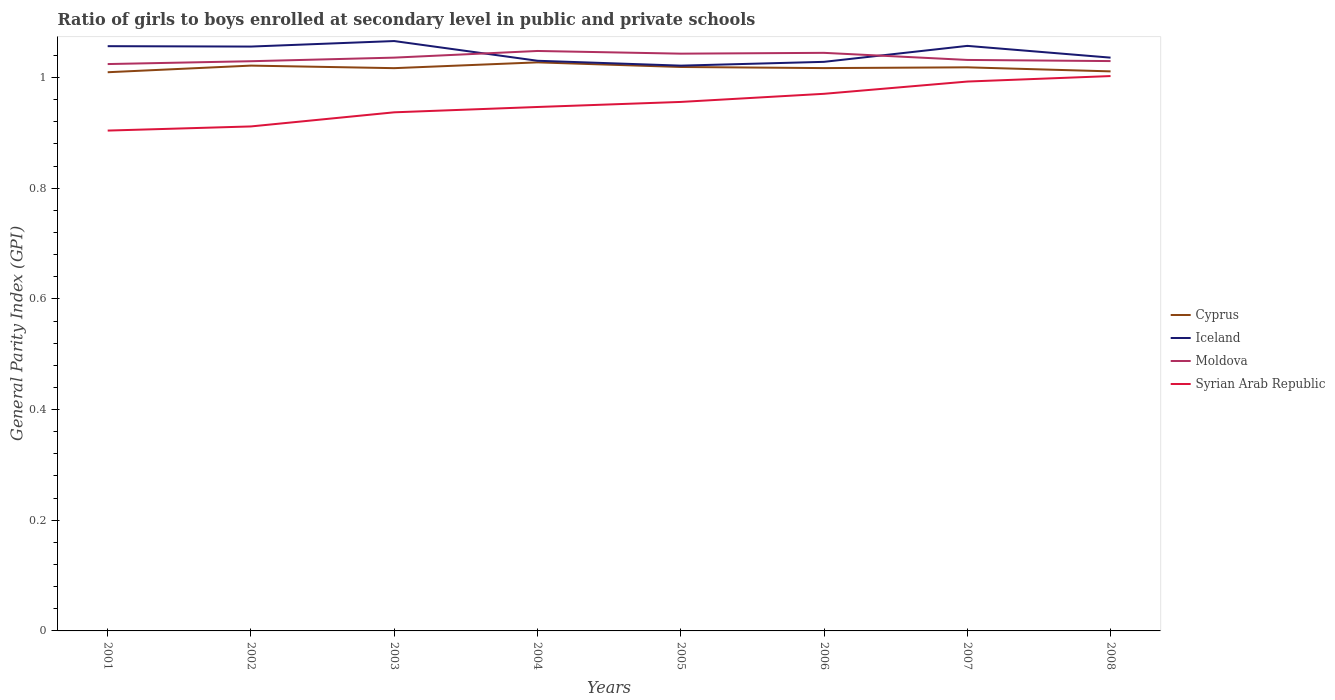How many different coloured lines are there?
Your response must be concise. 4. Does the line corresponding to Moldova intersect with the line corresponding to Iceland?
Make the answer very short. Yes. Across all years, what is the maximum general parity index in Moldova?
Your answer should be compact. 1.02. What is the total general parity index in Cyprus in the graph?
Ensure brevity in your answer.  -0. What is the difference between the highest and the second highest general parity index in Cyprus?
Give a very brief answer. 0.02. Is the general parity index in Iceland strictly greater than the general parity index in Syrian Arab Republic over the years?
Give a very brief answer. No. How many lines are there?
Provide a succinct answer. 4. Does the graph contain grids?
Make the answer very short. No. How many legend labels are there?
Keep it short and to the point. 4. What is the title of the graph?
Offer a terse response. Ratio of girls to boys enrolled at secondary level in public and private schools. Does "Greece" appear as one of the legend labels in the graph?
Your response must be concise. No. What is the label or title of the X-axis?
Ensure brevity in your answer.  Years. What is the label or title of the Y-axis?
Provide a short and direct response. General Parity Index (GPI). What is the General Parity Index (GPI) of Cyprus in 2001?
Offer a very short reply. 1.01. What is the General Parity Index (GPI) in Iceland in 2001?
Provide a succinct answer. 1.06. What is the General Parity Index (GPI) in Moldova in 2001?
Provide a short and direct response. 1.02. What is the General Parity Index (GPI) of Syrian Arab Republic in 2001?
Offer a terse response. 0.9. What is the General Parity Index (GPI) in Cyprus in 2002?
Provide a short and direct response. 1.02. What is the General Parity Index (GPI) in Iceland in 2002?
Your answer should be very brief. 1.06. What is the General Parity Index (GPI) in Moldova in 2002?
Provide a short and direct response. 1.03. What is the General Parity Index (GPI) of Syrian Arab Republic in 2002?
Give a very brief answer. 0.91. What is the General Parity Index (GPI) of Cyprus in 2003?
Make the answer very short. 1.02. What is the General Parity Index (GPI) of Iceland in 2003?
Your answer should be compact. 1.07. What is the General Parity Index (GPI) in Moldova in 2003?
Your response must be concise. 1.04. What is the General Parity Index (GPI) in Syrian Arab Republic in 2003?
Keep it short and to the point. 0.94. What is the General Parity Index (GPI) in Cyprus in 2004?
Keep it short and to the point. 1.03. What is the General Parity Index (GPI) in Iceland in 2004?
Provide a succinct answer. 1.03. What is the General Parity Index (GPI) in Moldova in 2004?
Your answer should be compact. 1.05. What is the General Parity Index (GPI) of Syrian Arab Republic in 2004?
Keep it short and to the point. 0.95. What is the General Parity Index (GPI) of Cyprus in 2005?
Give a very brief answer. 1.02. What is the General Parity Index (GPI) of Iceland in 2005?
Offer a very short reply. 1.02. What is the General Parity Index (GPI) of Moldova in 2005?
Ensure brevity in your answer.  1.04. What is the General Parity Index (GPI) in Syrian Arab Republic in 2005?
Provide a succinct answer. 0.96. What is the General Parity Index (GPI) of Cyprus in 2006?
Give a very brief answer. 1.02. What is the General Parity Index (GPI) in Iceland in 2006?
Offer a terse response. 1.03. What is the General Parity Index (GPI) in Moldova in 2006?
Offer a terse response. 1.04. What is the General Parity Index (GPI) of Syrian Arab Republic in 2006?
Provide a succinct answer. 0.97. What is the General Parity Index (GPI) of Cyprus in 2007?
Offer a very short reply. 1.02. What is the General Parity Index (GPI) of Iceland in 2007?
Your response must be concise. 1.06. What is the General Parity Index (GPI) in Moldova in 2007?
Give a very brief answer. 1.03. What is the General Parity Index (GPI) of Syrian Arab Republic in 2007?
Your response must be concise. 0.99. What is the General Parity Index (GPI) of Cyprus in 2008?
Ensure brevity in your answer.  1.01. What is the General Parity Index (GPI) of Iceland in 2008?
Give a very brief answer. 1.04. What is the General Parity Index (GPI) of Moldova in 2008?
Give a very brief answer. 1.03. What is the General Parity Index (GPI) of Syrian Arab Republic in 2008?
Offer a very short reply. 1. Across all years, what is the maximum General Parity Index (GPI) of Cyprus?
Make the answer very short. 1.03. Across all years, what is the maximum General Parity Index (GPI) in Iceland?
Ensure brevity in your answer.  1.07. Across all years, what is the maximum General Parity Index (GPI) of Moldova?
Keep it short and to the point. 1.05. Across all years, what is the maximum General Parity Index (GPI) of Syrian Arab Republic?
Provide a short and direct response. 1. Across all years, what is the minimum General Parity Index (GPI) of Cyprus?
Provide a succinct answer. 1.01. Across all years, what is the minimum General Parity Index (GPI) of Iceland?
Your answer should be very brief. 1.02. Across all years, what is the minimum General Parity Index (GPI) in Moldova?
Offer a terse response. 1.02. Across all years, what is the minimum General Parity Index (GPI) of Syrian Arab Republic?
Your answer should be very brief. 0.9. What is the total General Parity Index (GPI) of Cyprus in the graph?
Provide a short and direct response. 8.14. What is the total General Parity Index (GPI) of Iceland in the graph?
Offer a very short reply. 8.35. What is the total General Parity Index (GPI) of Moldova in the graph?
Offer a terse response. 8.29. What is the total General Parity Index (GPI) of Syrian Arab Republic in the graph?
Give a very brief answer. 7.62. What is the difference between the General Parity Index (GPI) in Cyprus in 2001 and that in 2002?
Make the answer very short. -0.01. What is the difference between the General Parity Index (GPI) in Iceland in 2001 and that in 2002?
Your response must be concise. 0. What is the difference between the General Parity Index (GPI) of Moldova in 2001 and that in 2002?
Your response must be concise. -0.01. What is the difference between the General Parity Index (GPI) in Syrian Arab Republic in 2001 and that in 2002?
Offer a terse response. -0.01. What is the difference between the General Parity Index (GPI) in Cyprus in 2001 and that in 2003?
Provide a short and direct response. -0.01. What is the difference between the General Parity Index (GPI) in Iceland in 2001 and that in 2003?
Your answer should be very brief. -0.01. What is the difference between the General Parity Index (GPI) in Moldova in 2001 and that in 2003?
Make the answer very short. -0.01. What is the difference between the General Parity Index (GPI) in Syrian Arab Republic in 2001 and that in 2003?
Keep it short and to the point. -0.03. What is the difference between the General Parity Index (GPI) of Cyprus in 2001 and that in 2004?
Offer a terse response. -0.02. What is the difference between the General Parity Index (GPI) of Iceland in 2001 and that in 2004?
Offer a very short reply. 0.03. What is the difference between the General Parity Index (GPI) in Moldova in 2001 and that in 2004?
Ensure brevity in your answer.  -0.02. What is the difference between the General Parity Index (GPI) in Syrian Arab Republic in 2001 and that in 2004?
Your response must be concise. -0.04. What is the difference between the General Parity Index (GPI) in Cyprus in 2001 and that in 2005?
Provide a short and direct response. -0.01. What is the difference between the General Parity Index (GPI) of Iceland in 2001 and that in 2005?
Offer a very short reply. 0.04. What is the difference between the General Parity Index (GPI) in Moldova in 2001 and that in 2005?
Give a very brief answer. -0.02. What is the difference between the General Parity Index (GPI) of Syrian Arab Republic in 2001 and that in 2005?
Provide a succinct answer. -0.05. What is the difference between the General Parity Index (GPI) of Cyprus in 2001 and that in 2006?
Offer a terse response. -0.01. What is the difference between the General Parity Index (GPI) of Iceland in 2001 and that in 2006?
Provide a succinct answer. 0.03. What is the difference between the General Parity Index (GPI) of Moldova in 2001 and that in 2006?
Give a very brief answer. -0.02. What is the difference between the General Parity Index (GPI) of Syrian Arab Republic in 2001 and that in 2006?
Your response must be concise. -0.07. What is the difference between the General Parity Index (GPI) of Cyprus in 2001 and that in 2007?
Give a very brief answer. -0.01. What is the difference between the General Parity Index (GPI) of Iceland in 2001 and that in 2007?
Your answer should be compact. -0. What is the difference between the General Parity Index (GPI) in Moldova in 2001 and that in 2007?
Make the answer very short. -0.01. What is the difference between the General Parity Index (GPI) in Syrian Arab Republic in 2001 and that in 2007?
Make the answer very short. -0.09. What is the difference between the General Parity Index (GPI) in Cyprus in 2001 and that in 2008?
Ensure brevity in your answer.  -0. What is the difference between the General Parity Index (GPI) in Iceland in 2001 and that in 2008?
Ensure brevity in your answer.  0.02. What is the difference between the General Parity Index (GPI) of Moldova in 2001 and that in 2008?
Your response must be concise. -0.01. What is the difference between the General Parity Index (GPI) of Syrian Arab Republic in 2001 and that in 2008?
Your answer should be compact. -0.1. What is the difference between the General Parity Index (GPI) in Cyprus in 2002 and that in 2003?
Your answer should be compact. 0. What is the difference between the General Parity Index (GPI) of Iceland in 2002 and that in 2003?
Your answer should be compact. -0.01. What is the difference between the General Parity Index (GPI) of Moldova in 2002 and that in 2003?
Your answer should be very brief. -0.01. What is the difference between the General Parity Index (GPI) of Syrian Arab Republic in 2002 and that in 2003?
Your response must be concise. -0.03. What is the difference between the General Parity Index (GPI) of Cyprus in 2002 and that in 2004?
Your answer should be very brief. -0.01. What is the difference between the General Parity Index (GPI) of Iceland in 2002 and that in 2004?
Give a very brief answer. 0.03. What is the difference between the General Parity Index (GPI) in Moldova in 2002 and that in 2004?
Provide a short and direct response. -0.02. What is the difference between the General Parity Index (GPI) in Syrian Arab Republic in 2002 and that in 2004?
Provide a succinct answer. -0.04. What is the difference between the General Parity Index (GPI) of Cyprus in 2002 and that in 2005?
Your response must be concise. 0. What is the difference between the General Parity Index (GPI) in Iceland in 2002 and that in 2005?
Provide a succinct answer. 0.03. What is the difference between the General Parity Index (GPI) of Moldova in 2002 and that in 2005?
Your response must be concise. -0.01. What is the difference between the General Parity Index (GPI) in Syrian Arab Republic in 2002 and that in 2005?
Your answer should be very brief. -0.04. What is the difference between the General Parity Index (GPI) in Cyprus in 2002 and that in 2006?
Make the answer very short. 0. What is the difference between the General Parity Index (GPI) in Iceland in 2002 and that in 2006?
Offer a terse response. 0.03. What is the difference between the General Parity Index (GPI) in Moldova in 2002 and that in 2006?
Provide a short and direct response. -0.02. What is the difference between the General Parity Index (GPI) in Syrian Arab Republic in 2002 and that in 2006?
Provide a succinct answer. -0.06. What is the difference between the General Parity Index (GPI) in Cyprus in 2002 and that in 2007?
Ensure brevity in your answer.  0. What is the difference between the General Parity Index (GPI) of Iceland in 2002 and that in 2007?
Offer a terse response. -0. What is the difference between the General Parity Index (GPI) in Moldova in 2002 and that in 2007?
Offer a terse response. -0. What is the difference between the General Parity Index (GPI) in Syrian Arab Republic in 2002 and that in 2007?
Make the answer very short. -0.08. What is the difference between the General Parity Index (GPI) in Cyprus in 2002 and that in 2008?
Ensure brevity in your answer.  0.01. What is the difference between the General Parity Index (GPI) in Moldova in 2002 and that in 2008?
Your answer should be compact. -0. What is the difference between the General Parity Index (GPI) in Syrian Arab Republic in 2002 and that in 2008?
Ensure brevity in your answer.  -0.09. What is the difference between the General Parity Index (GPI) of Cyprus in 2003 and that in 2004?
Give a very brief answer. -0.01. What is the difference between the General Parity Index (GPI) in Iceland in 2003 and that in 2004?
Your answer should be compact. 0.04. What is the difference between the General Parity Index (GPI) in Moldova in 2003 and that in 2004?
Your response must be concise. -0.01. What is the difference between the General Parity Index (GPI) in Syrian Arab Republic in 2003 and that in 2004?
Give a very brief answer. -0.01. What is the difference between the General Parity Index (GPI) in Cyprus in 2003 and that in 2005?
Give a very brief answer. -0. What is the difference between the General Parity Index (GPI) of Iceland in 2003 and that in 2005?
Make the answer very short. 0.04. What is the difference between the General Parity Index (GPI) of Moldova in 2003 and that in 2005?
Ensure brevity in your answer.  -0.01. What is the difference between the General Parity Index (GPI) in Syrian Arab Republic in 2003 and that in 2005?
Provide a succinct answer. -0.02. What is the difference between the General Parity Index (GPI) of Cyprus in 2003 and that in 2006?
Provide a short and direct response. -0. What is the difference between the General Parity Index (GPI) of Iceland in 2003 and that in 2006?
Keep it short and to the point. 0.04. What is the difference between the General Parity Index (GPI) in Moldova in 2003 and that in 2006?
Give a very brief answer. -0.01. What is the difference between the General Parity Index (GPI) in Syrian Arab Republic in 2003 and that in 2006?
Offer a terse response. -0.03. What is the difference between the General Parity Index (GPI) in Cyprus in 2003 and that in 2007?
Offer a very short reply. -0. What is the difference between the General Parity Index (GPI) of Iceland in 2003 and that in 2007?
Keep it short and to the point. 0.01. What is the difference between the General Parity Index (GPI) of Moldova in 2003 and that in 2007?
Provide a succinct answer. 0. What is the difference between the General Parity Index (GPI) of Syrian Arab Republic in 2003 and that in 2007?
Your response must be concise. -0.06. What is the difference between the General Parity Index (GPI) in Cyprus in 2003 and that in 2008?
Keep it short and to the point. 0.01. What is the difference between the General Parity Index (GPI) of Moldova in 2003 and that in 2008?
Give a very brief answer. 0.01. What is the difference between the General Parity Index (GPI) in Syrian Arab Republic in 2003 and that in 2008?
Ensure brevity in your answer.  -0.07. What is the difference between the General Parity Index (GPI) in Cyprus in 2004 and that in 2005?
Offer a terse response. 0.01. What is the difference between the General Parity Index (GPI) in Iceland in 2004 and that in 2005?
Your answer should be compact. 0.01. What is the difference between the General Parity Index (GPI) of Moldova in 2004 and that in 2005?
Offer a very short reply. 0. What is the difference between the General Parity Index (GPI) in Syrian Arab Republic in 2004 and that in 2005?
Offer a terse response. -0.01. What is the difference between the General Parity Index (GPI) of Cyprus in 2004 and that in 2006?
Your answer should be very brief. 0.01. What is the difference between the General Parity Index (GPI) in Iceland in 2004 and that in 2006?
Your response must be concise. 0. What is the difference between the General Parity Index (GPI) of Moldova in 2004 and that in 2006?
Keep it short and to the point. 0. What is the difference between the General Parity Index (GPI) of Syrian Arab Republic in 2004 and that in 2006?
Make the answer very short. -0.02. What is the difference between the General Parity Index (GPI) of Cyprus in 2004 and that in 2007?
Make the answer very short. 0.01. What is the difference between the General Parity Index (GPI) of Iceland in 2004 and that in 2007?
Offer a terse response. -0.03. What is the difference between the General Parity Index (GPI) in Moldova in 2004 and that in 2007?
Your answer should be very brief. 0.02. What is the difference between the General Parity Index (GPI) of Syrian Arab Republic in 2004 and that in 2007?
Provide a short and direct response. -0.05. What is the difference between the General Parity Index (GPI) in Cyprus in 2004 and that in 2008?
Keep it short and to the point. 0.02. What is the difference between the General Parity Index (GPI) in Iceland in 2004 and that in 2008?
Provide a short and direct response. -0.01. What is the difference between the General Parity Index (GPI) in Moldova in 2004 and that in 2008?
Offer a very short reply. 0.02. What is the difference between the General Parity Index (GPI) in Syrian Arab Republic in 2004 and that in 2008?
Offer a terse response. -0.06. What is the difference between the General Parity Index (GPI) in Cyprus in 2005 and that in 2006?
Ensure brevity in your answer.  0. What is the difference between the General Parity Index (GPI) of Iceland in 2005 and that in 2006?
Provide a succinct answer. -0.01. What is the difference between the General Parity Index (GPI) of Moldova in 2005 and that in 2006?
Offer a terse response. -0. What is the difference between the General Parity Index (GPI) in Syrian Arab Republic in 2005 and that in 2006?
Ensure brevity in your answer.  -0.01. What is the difference between the General Parity Index (GPI) of Cyprus in 2005 and that in 2007?
Offer a terse response. 0. What is the difference between the General Parity Index (GPI) in Iceland in 2005 and that in 2007?
Offer a terse response. -0.04. What is the difference between the General Parity Index (GPI) of Moldova in 2005 and that in 2007?
Provide a short and direct response. 0.01. What is the difference between the General Parity Index (GPI) in Syrian Arab Republic in 2005 and that in 2007?
Keep it short and to the point. -0.04. What is the difference between the General Parity Index (GPI) in Cyprus in 2005 and that in 2008?
Ensure brevity in your answer.  0.01. What is the difference between the General Parity Index (GPI) of Iceland in 2005 and that in 2008?
Your answer should be compact. -0.01. What is the difference between the General Parity Index (GPI) in Moldova in 2005 and that in 2008?
Your answer should be very brief. 0.01. What is the difference between the General Parity Index (GPI) of Syrian Arab Republic in 2005 and that in 2008?
Provide a succinct answer. -0.05. What is the difference between the General Parity Index (GPI) of Cyprus in 2006 and that in 2007?
Provide a succinct answer. -0. What is the difference between the General Parity Index (GPI) in Iceland in 2006 and that in 2007?
Offer a very short reply. -0.03. What is the difference between the General Parity Index (GPI) in Moldova in 2006 and that in 2007?
Your response must be concise. 0.01. What is the difference between the General Parity Index (GPI) of Syrian Arab Republic in 2006 and that in 2007?
Your answer should be very brief. -0.02. What is the difference between the General Parity Index (GPI) of Cyprus in 2006 and that in 2008?
Make the answer very short. 0.01. What is the difference between the General Parity Index (GPI) in Iceland in 2006 and that in 2008?
Your response must be concise. -0.01. What is the difference between the General Parity Index (GPI) of Moldova in 2006 and that in 2008?
Give a very brief answer. 0.01. What is the difference between the General Parity Index (GPI) in Syrian Arab Republic in 2006 and that in 2008?
Your answer should be compact. -0.03. What is the difference between the General Parity Index (GPI) in Cyprus in 2007 and that in 2008?
Your response must be concise. 0.01. What is the difference between the General Parity Index (GPI) of Iceland in 2007 and that in 2008?
Your answer should be compact. 0.02. What is the difference between the General Parity Index (GPI) in Moldova in 2007 and that in 2008?
Your response must be concise. 0. What is the difference between the General Parity Index (GPI) in Syrian Arab Republic in 2007 and that in 2008?
Your answer should be compact. -0.01. What is the difference between the General Parity Index (GPI) of Cyprus in 2001 and the General Parity Index (GPI) of Iceland in 2002?
Provide a succinct answer. -0.05. What is the difference between the General Parity Index (GPI) in Cyprus in 2001 and the General Parity Index (GPI) in Moldova in 2002?
Provide a short and direct response. -0.02. What is the difference between the General Parity Index (GPI) in Cyprus in 2001 and the General Parity Index (GPI) in Syrian Arab Republic in 2002?
Your answer should be compact. 0.1. What is the difference between the General Parity Index (GPI) of Iceland in 2001 and the General Parity Index (GPI) of Moldova in 2002?
Your answer should be very brief. 0.03. What is the difference between the General Parity Index (GPI) of Iceland in 2001 and the General Parity Index (GPI) of Syrian Arab Republic in 2002?
Keep it short and to the point. 0.14. What is the difference between the General Parity Index (GPI) in Moldova in 2001 and the General Parity Index (GPI) in Syrian Arab Republic in 2002?
Ensure brevity in your answer.  0.11. What is the difference between the General Parity Index (GPI) of Cyprus in 2001 and the General Parity Index (GPI) of Iceland in 2003?
Offer a terse response. -0.06. What is the difference between the General Parity Index (GPI) of Cyprus in 2001 and the General Parity Index (GPI) of Moldova in 2003?
Provide a short and direct response. -0.03. What is the difference between the General Parity Index (GPI) of Cyprus in 2001 and the General Parity Index (GPI) of Syrian Arab Republic in 2003?
Your response must be concise. 0.07. What is the difference between the General Parity Index (GPI) in Iceland in 2001 and the General Parity Index (GPI) in Moldova in 2003?
Provide a short and direct response. 0.02. What is the difference between the General Parity Index (GPI) in Iceland in 2001 and the General Parity Index (GPI) in Syrian Arab Republic in 2003?
Your answer should be compact. 0.12. What is the difference between the General Parity Index (GPI) of Moldova in 2001 and the General Parity Index (GPI) of Syrian Arab Republic in 2003?
Provide a succinct answer. 0.09. What is the difference between the General Parity Index (GPI) in Cyprus in 2001 and the General Parity Index (GPI) in Iceland in 2004?
Ensure brevity in your answer.  -0.02. What is the difference between the General Parity Index (GPI) in Cyprus in 2001 and the General Parity Index (GPI) in Moldova in 2004?
Your response must be concise. -0.04. What is the difference between the General Parity Index (GPI) in Cyprus in 2001 and the General Parity Index (GPI) in Syrian Arab Republic in 2004?
Ensure brevity in your answer.  0.06. What is the difference between the General Parity Index (GPI) in Iceland in 2001 and the General Parity Index (GPI) in Moldova in 2004?
Your response must be concise. 0.01. What is the difference between the General Parity Index (GPI) in Iceland in 2001 and the General Parity Index (GPI) in Syrian Arab Republic in 2004?
Your response must be concise. 0.11. What is the difference between the General Parity Index (GPI) of Moldova in 2001 and the General Parity Index (GPI) of Syrian Arab Republic in 2004?
Your answer should be compact. 0.08. What is the difference between the General Parity Index (GPI) in Cyprus in 2001 and the General Parity Index (GPI) in Iceland in 2005?
Your answer should be compact. -0.01. What is the difference between the General Parity Index (GPI) in Cyprus in 2001 and the General Parity Index (GPI) in Moldova in 2005?
Your response must be concise. -0.03. What is the difference between the General Parity Index (GPI) in Cyprus in 2001 and the General Parity Index (GPI) in Syrian Arab Republic in 2005?
Ensure brevity in your answer.  0.05. What is the difference between the General Parity Index (GPI) of Iceland in 2001 and the General Parity Index (GPI) of Moldova in 2005?
Keep it short and to the point. 0.01. What is the difference between the General Parity Index (GPI) of Iceland in 2001 and the General Parity Index (GPI) of Syrian Arab Republic in 2005?
Ensure brevity in your answer.  0.1. What is the difference between the General Parity Index (GPI) of Moldova in 2001 and the General Parity Index (GPI) of Syrian Arab Republic in 2005?
Your answer should be compact. 0.07. What is the difference between the General Parity Index (GPI) of Cyprus in 2001 and the General Parity Index (GPI) of Iceland in 2006?
Your answer should be compact. -0.02. What is the difference between the General Parity Index (GPI) of Cyprus in 2001 and the General Parity Index (GPI) of Moldova in 2006?
Offer a terse response. -0.04. What is the difference between the General Parity Index (GPI) in Cyprus in 2001 and the General Parity Index (GPI) in Syrian Arab Republic in 2006?
Give a very brief answer. 0.04. What is the difference between the General Parity Index (GPI) of Iceland in 2001 and the General Parity Index (GPI) of Moldova in 2006?
Your answer should be compact. 0.01. What is the difference between the General Parity Index (GPI) in Iceland in 2001 and the General Parity Index (GPI) in Syrian Arab Republic in 2006?
Offer a terse response. 0.09. What is the difference between the General Parity Index (GPI) in Moldova in 2001 and the General Parity Index (GPI) in Syrian Arab Republic in 2006?
Your response must be concise. 0.05. What is the difference between the General Parity Index (GPI) of Cyprus in 2001 and the General Parity Index (GPI) of Iceland in 2007?
Keep it short and to the point. -0.05. What is the difference between the General Parity Index (GPI) in Cyprus in 2001 and the General Parity Index (GPI) in Moldova in 2007?
Your answer should be very brief. -0.02. What is the difference between the General Parity Index (GPI) in Cyprus in 2001 and the General Parity Index (GPI) in Syrian Arab Republic in 2007?
Ensure brevity in your answer.  0.02. What is the difference between the General Parity Index (GPI) in Iceland in 2001 and the General Parity Index (GPI) in Moldova in 2007?
Keep it short and to the point. 0.02. What is the difference between the General Parity Index (GPI) of Iceland in 2001 and the General Parity Index (GPI) of Syrian Arab Republic in 2007?
Give a very brief answer. 0.06. What is the difference between the General Parity Index (GPI) in Moldova in 2001 and the General Parity Index (GPI) in Syrian Arab Republic in 2007?
Keep it short and to the point. 0.03. What is the difference between the General Parity Index (GPI) of Cyprus in 2001 and the General Parity Index (GPI) of Iceland in 2008?
Your answer should be very brief. -0.03. What is the difference between the General Parity Index (GPI) of Cyprus in 2001 and the General Parity Index (GPI) of Moldova in 2008?
Ensure brevity in your answer.  -0.02. What is the difference between the General Parity Index (GPI) of Cyprus in 2001 and the General Parity Index (GPI) of Syrian Arab Republic in 2008?
Give a very brief answer. 0.01. What is the difference between the General Parity Index (GPI) in Iceland in 2001 and the General Parity Index (GPI) in Moldova in 2008?
Provide a short and direct response. 0.03. What is the difference between the General Parity Index (GPI) in Iceland in 2001 and the General Parity Index (GPI) in Syrian Arab Republic in 2008?
Your response must be concise. 0.05. What is the difference between the General Parity Index (GPI) in Moldova in 2001 and the General Parity Index (GPI) in Syrian Arab Republic in 2008?
Keep it short and to the point. 0.02. What is the difference between the General Parity Index (GPI) in Cyprus in 2002 and the General Parity Index (GPI) in Iceland in 2003?
Your response must be concise. -0.04. What is the difference between the General Parity Index (GPI) in Cyprus in 2002 and the General Parity Index (GPI) in Moldova in 2003?
Make the answer very short. -0.01. What is the difference between the General Parity Index (GPI) in Cyprus in 2002 and the General Parity Index (GPI) in Syrian Arab Republic in 2003?
Offer a very short reply. 0.08. What is the difference between the General Parity Index (GPI) of Iceland in 2002 and the General Parity Index (GPI) of Syrian Arab Republic in 2003?
Your answer should be very brief. 0.12. What is the difference between the General Parity Index (GPI) in Moldova in 2002 and the General Parity Index (GPI) in Syrian Arab Republic in 2003?
Keep it short and to the point. 0.09. What is the difference between the General Parity Index (GPI) in Cyprus in 2002 and the General Parity Index (GPI) in Iceland in 2004?
Your response must be concise. -0.01. What is the difference between the General Parity Index (GPI) in Cyprus in 2002 and the General Parity Index (GPI) in Moldova in 2004?
Your answer should be compact. -0.03. What is the difference between the General Parity Index (GPI) of Cyprus in 2002 and the General Parity Index (GPI) of Syrian Arab Republic in 2004?
Your answer should be compact. 0.07. What is the difference between the General Parity Index (GPI) of Iceland in 2002 and the General Parity Index (GPI) of Moldova in 2004?
Your answer should be very brief. 0.01. What is the difference between the General Parity Index (GPI) in Iceland in 2002 and the General Parity Index (GPI) in Syrian Arab Republic in 2004?
Make the answer very short. 0.11. What is the difference between the General Parity Index (GPI) of Moldova in 2002 and the General Parity Index (GPI) of Syrian Arab Republic in 2004?
Make the answer very short. 0.08. What is the difference between the General Parity Index (GPI) of Cyprus in 2002 and the General Parity Index (GPI) of Moldova in 2005?
Ensure brevity in your answer.  -0.02. What is the difference between the General Parity Index (GPI) of Cyprus in 2002 and the General Parity Index (GPI) of Syrian Arab Republic in 2005?
Provide a short and direct response. 0.07. What is the difference between the General Parity Index (GPI) of Iceland in 2002 and the General Parity Index (GPI) of Moldova in 2005?
Provide a succinct answer. 0.01. What is the difference between the General Parity Index (GPI) in Iceland in 2002 and the General Parity Index (GPI) in Syrian Arab Republic in 2005?
Your response must be concise. 0.1. What is the difference between the General Parity Index (GPI) of Moldova in 2002 and the General Parity Index (GPI) of Syrian Arab Republic in 2005?
Your response must be concise. 0.07. What is the difference between the General Parity Index (GPI) of Cyprus in 2002 and the General Parity Index (GPI) of Iceland in 2006?
Provide a succinct answer. -0.01. What is the difference between the General Parity Index (GPI) in Cyprus in 2002 and the General Parity Index (GPI) in Moldova in 2006?
Keep it short and to the point. -0.02. What is the difference between the General Parity Index (GPI) in Cyprus in 2002 and the General Parity Index (GPI) in Syrian Arab Republic in 2006?
Your answer should be very brief. 0.05. What is the difference between the General Parity Index (GPI) of Iceland in 2002 and the General Parity Index (GPI) of Moldova in 2006?
Give a very brief answer. 0.01. What is the difference between the General Parity Index (GPI) of Iceland in 2002 and the General Parity Index (GPI) of Syrian Arab Republic in 2006?
Make the answer very short. 0.09. What is the difference between the General Parity Index (GPI) of Moldova in 2002 and the General Parity Index (GPI) of Syrian Arab Republic in 2006?
Make the answer very short. 0.06. What is the difference between the General Parity Index (GPI) of Cyprus in 2002 and the General Parity Index (GPI) of Iceland in 2007?
Offer a terse response. -0.04. What is the difference between the General Parity Index (GPI) of Cyprus in 2002 and the General Parity Index (GPI) of Moldova in 2007?
Ensure brevity in your answer.  -0.01. What is the difference between the General Parity Index (GPI) in Cyprus in 2002 and the General Parity Index (GPI) in Syrian Arab Republic in 2007?
Make the answer very short. 0.03. What is the difference between the General Parity Index (GPI) in Iceland in 2002 and the General Parity Index (GPI) in Moldova in 2007?
Give a very brief answer. 0.02. What is the difference between the General Parity Index (GPI) in Iceland in 2002 and the General Parity Index (GPI) in Syrian Arab Republic in 2007?
Your answer should be very brief. 0.06. What is the difference between the General Parity Index (GPI) of Moldova in 2002 and the General Parity Index (GPI) of Syrian Arab Republic in 2007?
Your answer should be compact. 0.04. What is the difference between the General Parity Index (GPI) of Cyprus in 2002 and the General Parity Index (GPI) of Iceland in 2008?
Provide a succinct answer. -0.01. What is the difference between the General Parity Index (GPI) in Cyprus in 2002 and the General Parity Index (GPI) in Moldova in 2008?
Your response must be concise. -0.01. What is the difference between the General Parity Index (GPI) in Cyprus in 2002 and the General Parity Index (GPI) in Syrian Arab Republic in 2008?
Provide a succinct answer. 0.02. What is the difference between the General Parity Index (GPI) of Iceland in 2002 and the General Parity Index (GPI) of Moldova in 2008?
Make the answer very short. 0.03. What is the difference between the General Parity Index (GPI) in Iceland in 2002 and the General Parity Index (GPI) in Syrian Arab Republic in 2008?
Your answer should be very brief. 0.05. What is the difference between the General Parity Index (GPI) of Moldova in 2002 and the General Parity Index (GPI) of Syrian Arab Republic in 2008?
Ensure brevity in your answer.  0.03. What is the difference between the General Parity Index (GPI) in Cyprus in 2003 and the General Parity Index (GPI) in Iceland in 2004?
Your answer should be very brief. -0.01. What is the difference between the General Parity Index (GPI) of Cyprus in 2003 and the General Parity Index (GPI) of Moldova in 2004?
Ensure brevity in your answer.  -0.03. What is the difference between the General Parity Index (GPI) in Cyprus in 2003 and the General Parity Index (GPI) in Syrian Arab Republic in 2004?
Your answer should be very brief. 0.07. What is the difference between the General Parity Index (GPI) of Iceland in 2003 and the General Parity Index (GPI) of Moldova in 2004?
Provide a succinct answer. 0.02. What is the difference between the General Parity Index (GPI) in Iceland in 2003 and the General Parity Index (GPI) in Syrian Arab Republic in 2004?
Your answer should be compact. 0.12. What is the difference between the General Parity Index (GPI) in Moldova in 2003 and the General Parity Index (GPI) in Syrian Arab Republic in 2004?
Your answer should be very brief. 0.09. What is the difference between the General Parity Index (GPI) of Cyprus in 2003 and the General Parity Index (GPI) of Iceland in 2005?
Make the answer very short. -0. What is the difference between the General Parity Index (GPI) in Cyprus in 2003 and the General Parity Index (GPI) in Moldova in 2005?
Offer a terse response. -0.03. What is the difference between the General Parity Index (GPI) of Cyprus in 2003 and the General Parity Index (GPI) of Syrian Arab Republic in 2005?
Provide a succinct answer. 0.06. What is the difference between the General Parity Index (GPI) in Iceland in 2003 and the General Parity Index (GPI) in Moldova in 2005?
Make the answer very short. 0.02. What is the difference between the General Parity Index (GPI) in Iceland in 2003 and the General Parity Index (GPI) in Syrian Arab Republic in 2005?
Keep it short and to the point. 0.11. What is the difference between the General Parity Index (GPI) in Moldova in 2003 and the General Parity Index (GPI) in Syrian Arab Republic in 2005?
Provide a short and direct response. 0.08. What is the difference between the General Parity Index (GPI) in Cyprus in 2003 and the General Parity Index (GPI) in Iceland in 2006?
Make the answer very short. -0.01. What is the difference between the General Parity Index (GPI) of Cyprus in 2003 and the General Parity Index (GPI) of Moldova in 2006?
Your response must be concise. -0.03. What is the difference between the General Parity Index (GPI) in Cyprus in 2003 and the General Parity Index (GPI) in Syrian Arab Republic in 2006?
Ensure brevity in your answer.  0.05. What is the difference between the General Parity Index (GPI) of Iceland in 2003 and the General Parity Index (GPI) of Moldova in 2006?
Give a very brief answer. 0.02. What is the difference between the General Parity Index (GPI) of Iceland in 2003 and the General Parity Index (GPI) of Syrian Arab Republic in 2006?
Ensure brevity in your answer.  0.1. What is the difference between the General Parity Index (GPI) in Moldova in 2003 and the General Parity Index (GPI) in Syrian Arab Republic in 2006?
Provide a short and direct response. 0.07. What is the difference between the General Parity Index (GPI) of Cyprus in 2003 and the General Parity Index (GPI) of Iceland in 2007?
Give a very brief answer. -0.04. What is the difference between the General Parity Index (GPI) in Cyprus in 2003 and the General Parity Index (GPI) in Moldova in 2007?
Your answer should be compact. -0.01. What is the difference between the General Parity Index (GPI) in Cyprus in 2003 and the General Parity Index (GPI) in Syrian Arab Republic in 2007?
Provide a short and direct response. 0.02. What is the difference between the General Parity Index (GPI) in Iceland in 2003 and the General Parity Index (GPI) in Moldova in 2007?
Give a very brief answer. 0.03. What is the difference between the General Parity Index (GPI) in Iceland in 2003 and the General Parity Index (GPI) in Syrian Arab Republic in 2007?
Keep it short and to the point. 0.07. What is the difference between the General Parity Index (GPI) in Moldova in 2003 and the General Parity Index (GPI) in Syrian Arab Republic in 2007?
Provide a short and direct response. 0.04. What is the difference between the General Parity Index (GPI) of Cyprus in 2003 and the General Parity Index (GPI) of Iceland in 2008?
Offer a very short reply. -0.02. What is the difference between the General Parity Index (GPI) of Cyprus in 2003 and the General Parity Index (GPI) of Moldova in 2008?
Offer a terse response. -0.01. What is the difference between the General Parity Index (GPI) in Cyprus in 2003 and the General Parity Index (GPI) in Syrian Arab Republic in 2008?
Ensure brevity in your answer.  0.01. What is the difference between the General Parity Index (GPI) of Iceland in 2003 and the General Parity Index (GPI) of Moldova in 2008?
Offer a terse response. 0.04. What is the difference between the General Parity Index (GPI) in Iceland in 2003 and the General Parity Index (GPI) in Syrian Arab Republic in 2008?
Provide a short and direct response. 0.06. What is the difference between the General Parity Index (GPI) of Moldova in 2003 and the General Parity Index (GPI) of Syrian Arab Republic in 2008?
Your answer should be very brief. 0.03. What is the difference between the General Parity Index (GPI) of Cyprus in 2004 and the General Parity Index (GPI) of Iceland in 2005?
Keep it short and to the point. 0.01. What is the difference between the General Parity Index (GPI) of Cyprus in 2004 and the General Parity Index (GPI) of Moldova in 2005?
Provide a short and direct response. -0.02. What is the difference between the General Parity Index (GPI) in Cyprus in 2004 and the General Parity Index (GPI) in Syrian Arab Republic in 2005?
Provide a short and direct response. 0.07. What is the difference between the General Parity Index (GPI) of Iceland in 2004 and the General Parity Index (GPI) of Moldova in 2005?
Make the answer very short. -0.01. What is the difference between the General Parity Index (GPI) of Iceland in 2004 and the General Parity Index (GPI) of Syrian Arab Republic in 2005?
Offer a terse response. 0.07. What is the difference between the General Parity Index (GPI) of Moldova in 2004 and the General Parity Index (GPI) of Syrian Arab Republic in 2005?
Give a very brief answer. 0.09. What is the difference between the General Parity Index (GPI) of Cyprus in 2004 and the General Parity Index (GPI) of Iceland in 2006?
Provide a succinct answer. -0. What is the difference between the General Parity Index (GPI) in Cyprus in 2004 and the General Parity Index (GPI) in Moldova in 2006?
Offer a terse response. -0.02. What is the difference between the General Parity Index (GPI) of Cyprus in 2004 and the General Parity Index (GPI) of Syrian Arab Republic in 2006?
Your response must be concise. 0.06. What is the difference between the General Parity Index (GPI) of Iceland in 2004 and the General Parity Index (GPI) of Moldova in 2006?
Provide a succinct answer. -0.01. What is the difference between the General Parity Index (GPI) of Iceland in 2004 and the General Parity Index (GPI) of Syrian Arab Republic in 2006?
Make the answer very short. 0.06. What is the difference between the General Parity Index (GPI) of Moldova in 2004 and the General Parity Index (GPI) of Syrian Arab Republic in 2006?
Provide a succinct answer. 0.08. What is the difference between the General Parity Index (GPI) of Cyprus in 2004 and the General Parity Index (GPI) of Iceland in 2007?
Offer a very short reply. -0.03. What is the difference between the General Parity Index (GPI) in Cyprus in 2004 and the General Parity Index (GPI) in Moldova in 2007?
Offer a very short reply. -0. What is the difference between the General Parity Index (GPI) of Cyprus in 2004 and the General Parity Index (GPI) of Syrian Arab Republic in 2007?
Ensure brevity in your answer.  0.03. What is the difference between the General Parity Index (GPI) of Iceland in 2004 and the General Parity Index (GPI) of Moldova in 2007?
Offer a terse response. -0. What is the difference between the General Parity Index (GPI) of Iceland in 2004 and the General Parity Index (GPI) of Syrian Arab Republic in 2007?
Make the answer very short. 0.04. What is the difference between the General Parity Index (GPI) of Moldova in 2004 and the General Parity Index (GPI) of Syrian Arab Republic in 2007?
Ensure brevity in your answer.  0.06. What is the difference between the General Parity Index (GPI) of Cyprus in 2004 and the General Parity Index (GPI) of Iceland in 2008?
Make the answer very short. -0.01. What is the difference between the General Parity Index (GPI) of Cyprus in 2004 and the General Parity Index (GPI) of Moldova in 2008?
Offer a very short reply. -0. What is the difference between the General Parity Index (GPI) of Cyprus in 2004 and the General Parity Index (GPI) of Syrian Arab Republic in 2008?
Your response must be concise. 0.02. What is the difference between the General Parity Index (GPI) of Iceland in 2004 and the General Parity Index (GPI) of Moldova in 2008?
Keep it short and to the point. 0. What is the difference between the General Parity Index (GPI) of Iceland in 2004 and the General Parity Index (GPI) of Syrian Arab Republic in 2008?
Provide a short and direct response. 0.03. What is the difference between the General Parity Index (GPI) in Moldova in 2004 and the General Parity Index (GPI) in Syrian Arab Republic in 2008?
Offer a very short reply. 0.05. What is the difference between the General Parity Index (GPI) in Cyprus in 2005 and the General Parity Index (GPI) in Iceland in 2006?
Your response must be concise. -0.01. What is the difference between the General Parity Index (GPI) in Cyprus in 2005 and the General Parity Index (GPI) in Moldova in 2006?
Offer a terse response. -0.03. What is the difference between the General Parity Index (GPI) of Cyprus in 2005 and the General Parity Index (GPI) of Syrian Arab Republic in 2006?
Offer a very short reply. 0.05. What is the difference between the General Parity Index (GPI) in Iceland in 2005 and the General Parity Index (GPI) in Moldova in 2006?
Keep it short and to the point. -0.02. What is the difference between the General Parity Index (GPI) of Iceland in 2005 and the General Parity Index (GPI) of Syrian Arab Republic in 2006?
Your answer should be very brief. 0.05. What is the difference between the General Parity Index (GPI) of Moldova in 2005 and the General Parity Index (GPI) of Syrian Arab Republic in 2006?
Give a very brief answer. 0.07. What is the difference between the General Parity Index (GPI) in Cyprus in 2005 and the General Parity Index (GPI) in Iceland in 2007?
Offer a terse response. -0.04. What is the difference between the General Parity Index (GPI) of Cyprus in 2005 and the General Parity Index (GPI) of Moldova in 2007?
Offer a terse response. -0.01. What is the difference between the General Parity Index (GPI) of Cyprus in 2005 and the General Parity Index (GPI) of Syrian Arab Republic in 2007?
Offer a terse response. 0.03. What is the difference between the General Parity Index (GPI) in Iceland in 2005 and the General Parity Index (GPI) in Moldova in 2007?
Offer a very short reply. -0.01. What is the difference between the General Parity Index (GPI) in Iceland in 2005 and the General Parity Index (GPI) in Syrian Arab Republic in 2007?
Give a very brief answer. 0.03. What is the difference between the General Parity Index (GPI) of Moldova in 2005 and the General Parity Index (GPI) of Syrian Arab Republic in 2007?
Offer a terse response. 0.05. What is the difference between the General Parity Index (GPI) in Cyprus in 2005 and the General Parity Index (GPI) in Iceland in 2008?
Give a very brief answer. -0.02. What is the difference between the General Parity Index (GPI) in Cyprus in 2005 and the General Parity Index (GPI) in Moldova in 2008?
Your response must be concise. -0.01. What is the difference between the General Parity Index (GPI) of Cyprus in 2005 and the General Parity Index (GPI) of Syrian Arab Republic in 2008?
Provide a succinct answer. 0.02. What is the difference between the General Parity Index (GPI) in Iceland in 2005 and the General Parity Index (GPI) in Moldova in 2008?
Keep it short and to the point. -0.01. What is the difference between the General Parity Index (GPI) in Iceland in 2005 and the General Parity Index (GPI) in Syrian Arab Republic in 2008?
Your answer should be very brief. 0.02. What is the difference between the General Parity Index (GPI) in Moldova in 2005 and the General Parity Index (GPI) in Syrian Arab Republic in 2008?
Ensure brevity in your answer.  0.04. What is the difference between the General Parity Index (GPI) of Cyprus in 2006 and the General Parity Index (GPI) of Iceland in 2007?
Keep it short and to the point. -0.04. What is the difference between the General Parity Index (GPI) in Cyprus in 2006 and the General Parity Index (GPI) in Moldova in 2007?
Give a very brief answer. -0.01. What is the difference between the General Parity Index (GPI) of Cyprus in 2006 and the General Parity Index (GPI) of Syrian Arab Republic in 2007?
Give a very brief answer. 0.02. What is the difference between the General Parity Index (GPI) in Iceland in 2006 and the General Parity Index (GPI) in Moldova in 2007?
Keep it short and to the point. -0. What is the difference between the General Parity Index (GPI) of Iceland in 2006 and the General Parity Index (GPI) of Syrian Arab Republic in 2007?
Your answer should be very brief. 0.04. What is the difference between the General Parity Index (GPI) of Moldova in 2006 and the General Parity Index (GPI) of Syrian Arab Republic in 2007?
Ensure brevity in your answer.  0.05. What is the difference between the General Parity Index (GPI) in Cyprus in 2006 and the General Parity Index (GPI) in Iceland in 2008?
Keep it short and to the point. -0.02. What is the difference between the General Parity Index (GPI) of Cyprus in 2006 and the General Parity Index (GPI) of Moldova in 2008?
Provide a succinct answer. -0.01. What is the difference between the General Parity Index (GPI) in Cyprus in 2006 and the General Parity Index (GPI) in Syrian Arab Republic in 2008?
Ensure brevity in your answer.  0.01. What is the difference between the General Parity Index (GPI) of Iceland in 2006 and the General Parity Index (GPI) of Moldova in 2008?
Keep it short and to the point. -0. What is the difference between the General Parity Index (GPI) of Iceland in 2006 and the General Parity Index (GPI) of Syrian Arab Republic in 2008?
Keep it short and to the point. 0.03. What is the difference between the General Parity Index (GPI) of Moldova in 2006 and the General Parity Index (GPI) of Syrian Arab Republic in 2008?
Your response must be concise. 0.04. What is the difference between the General Parity Index (GPI) in Cyprus in 2007 and the General Parity Index (GPI) in Iceland in 2008?
Offer a very short reply. -0.02. What is the difference between the General Parity Index (GPI) in Cyprus in 2007 and the General Parity Index (GPI) in Moldova in 2008?
Make the answer very short. -0.01. What is the difference between the General Parity Index (GPI) of Cyprus in 2007 and the General Parity Index (GPI) of Syrian Arab Republic in 2008?
Offer a very short reply. 0.02. What is the difference between the General Parity Index (GPI) in Iceland in 2007 and the General Parity Index (GPI) in Moldova in 2008?
Your answer should be compact. 0.03. What is the difference between the General Parity Index (GPI) of Iceland in 2007 and the General Parity Index (GPI) of Syrian Arab Republic in 2008?
Offer a very short reply. 0.05. What is the difference between the General Parity Index (GPI) in Moldova in 2007 and the General Parity Index (GPI) in Syrian Arab Republic in 2008?
Offer a very short reply. 0.03. What is the average General Parity Index (GPI) in Cyprus per year?
Make the answer very short. 1.02. What is the average General Parity Index (GPI) in Iceland per year?
Your answer should be compact. 1.04. What is the average General Parity Index (GPI) in Moldova per year?
Provide a succinct answer. 1.04. What is the average General Parity Index (GPI) of Syrian Arab Republic per year?
Provide a succinct answer. 0.95. In the year 2001, what is the difference between the General Parity Index (GPI) of Cyprus and General Parity Index (GPI) of Iceland?
Offer a very short reply. -0.05. In the year 2001, what is the difference between the General Parity Index (GPI) of Cyprus and General Parity Index (GPI) of Moldova?
Make the answer very short. -0.01. In the year 2001, what is the difference between the General Parity Index (GPI) of Cyprus and General Parity Index (GPI) of Syrian Arab Republic?
Keep it short and to the point. 0.11. In the year 2001, what is the difference between the General Parity Index (GPI) of Iceland and General Parity Index (GPI) of Moldova?
Ensure brevity in your answer.  0.03. In the year 2001, what is the difference between the General Parity Index (GPI) of Iceland and General Parity Index (GPI) of Syrian Arab Republic?
Your response must be concise. 0.15. In the year 2001, what is the difference between the General Parity Index (GPI) of Moldova and General Parity Index (GPI) of Syrian Arab Republic?
Keep it short and to the point. 0.12. In the year 2002, what is the difference between the General Parity Index (GPI) of Cyprus and General Parity Index (GPI) of Iceland?
Make the answer very short. -0.03. In the year 2002, what is the difference between the General Parity Index (GPI) of Cyprus and General Parity Index (GPI) of Moldova?
Offer a terse response. -0.01. In the year 2002, what is the difference between the General Parity Index (GPI) of Cyprus and General Parity Index (GPI) of Syrian Arab Republic?
Provide a short and direct response. 0.11. In the year 2002, what is the difference between the General Parity Index (GPI) of Iceland and General Parity Index (GPI) of Moldova?
Keep it short and to the point. 0.03. In the year 2002, what is the difference between the General Parity Index (GPI) in Iceland and General Parity Index (GPI) in Syrian Arab Republic?
Keep it short and to the point. 0.14. In the year 2002, what is the difference between the General Parity Index (GPI) of Moldova and General Parity Index (GPI) of Syrian Arab Republic?
Your answer should be very brief. 0.12. In the year 2003, what is the difference between the General Parity Index (GPI) in Cyprus and General Parity Index (GPI) in Iceland?
Provide a succinct answer. -0.05. In the year 2003, what is the difference between the General Parity Index (GPI) of Cyprus and General Parity Index (GPI) of Moldova?
Offer a terse response. -0.02. In the year 2003, what is the difference between the General Parity Index (GPI) of Cyprus and General Parity Index (GPI) of Syrian Arab Republic?
Ensure brevity in your answer.  0.08. In the year 2003, what is the difference between the General Parity Index (GPI) in Iceland and General Parity Index (GPI) in Moldova?
Provide a succinct answer. 0.03. In the year 2003, what is the difference between the General Parity Index (GPI) in Iceland and General Parity Index (GPI) in Syrian Arab Republic?
Provide a succinct answer. 0.13. In the year 2003, what is the difference between the General Parity Index (GPI) of Moldova and General Parity Index (GPI) of Syrian Arab Republic?
Provide a short and direct response. 0.1. In the year 2004, what is the difference between the General Parity Index (GPI) of Cyprus and General Parity Index (GPI) of Iceland?
Give a very brief answer. -0. In the year 2004, what is the difference between the General Parity Index (GPI) in Cyprus and General Parity Index (GPI) in Moldova?
Your response must be concise. -0.02. In the year 2004, what is the difference between the General Parity Index (GPI) in Cyprus and General Parity Index (GPI) in Syrian Arab Republic?
Make the answer very short. 0.08. In the year 2004, what is the difference between the General Parity Index (GPI) in Iceland and General Parity Index (GPI) in Moldova?
Your response must be concise. -0.02. In the year 2004, what is the difference between the General Parity Index (GPI) in Iceland and General Parity Index (GPI) in Syrian Arab Republic?
Keep it short and to the point. 0.08. In the year 2004, what is the difference between the General Parity Index (GPI) in Moldova and General Parity Index (GPI) in Syrian Arab Republic?
Keep it short and to the point. 0.1. In the year 2005, what is the difference between the General Parity Index (GPI) of Cyprus and General Parity Index (GPI) of Iceland?
Keep it short and to the point. -0. In the year 2005, what is the difference between the General Parity Index (GPI) of Cyprus and General Parity Index (GPI) of Moldova?
Provide a short and direct response. -0.02. In the year 2005, what is the difference between the General Parity Index (GPI) in Cyprus and General Parity Index (GPI) in Syrian Arab Republic?
Provide a short and direct response. 0.06. In the year 2005, what is the difference between the General Parity Index (GPI) of Iceland and General Parity Index (GPI) of Moldova?
Your response must be concise. -0.02. In the year 2005, what is the difference between the General Parity Index (GPI) in Iceland and General Parity Index (GPI) in Syrian Arab Republic?
Offer a very short reply. 0.07. In the year 2005, what is the difference between the General Parity Index (GPI) in Moldova and General Parity Index (GPI) in Syrian Arab Republic?
Offer a terse response. 0.09. In the year 2006, what is the difference between the General Parity Index (GPI) in Cyprus and General Parity Index (GPI) in Iceland?
Your answer should be very brief. -0.01. In the year 2006, what is the difference between the General Parity Index (GPI) in Cyprus and General Parity Index (GPI) in Moldova?
Your answer should be compact. -0.03. In the year 2006, what is the difference between the General Parity Index (GPI) of Cyprus and General Parity Index (GPI) of Syrian Arab Republic?
Ensure brevity in your answer.  0.05. In the year 2006, what is the difference between the General Parity Index (GPI) in Iceland and General Parity Index (GPI) in Moldova?
Your response must be concise. -0.02. In the year 2006, what is the difference between the General Parity Index (GPI) in Iceland and General Parity Index (GPI) in Syrian Arab Republic?
Ensure brevity in your answer.  0.06. In the year 2006, what is the difference between the General Parity Index (GPI) of Moldova and General Parity Index (GPI) of Syrian Arab Republic?
Your answer should be very brief. 0.07. In the year 2007, what is the difference between the General Parity Index (GPI) of Cyprus and General Parity Index (GPI) of Iceland?
Your answer should be very brief. -0.04. In the year 2007, what is the difference between the General Parity Index (GPI) of Cyprus and General Parity Index (GPI) of Moldova?
Ensure brevity in your answer.  -0.01. In the year 2007, what is the difference between the General Parity Index (GPI) of Cyprus and General Parity Index (GPI) of Syrian Arab Republic?
Give a very brief answer. 0.03. In the year 2007, what is the difference between the General Parity Index (GPI) of Iceland and General Parity Index (GPI) of Moldova?
Your answer should be compact. 0.03. In the year 2007, what is the difference between the General Parity Index (GPI) in Iceland and General Parity Index (GPI) in Syrian Arab Republic?
Offer a terse response. 0.06. In the year 2007, what is the difference between the General Parity Index (GPI) in Moldova and General Parity Index (GPI) in Syrian Arab Republic?
Provide a short and direct response. 0.04. In the year 2008, what is the difference between the General Parity Index (GPI) in Cyprus and General Parity Index (GPI) in Iceland?
Offer a very short reply. -0.02. In the year 2008, what is the difference between the General Parity Index (GPI) in Cyprus and General Parity Index (GPI) in Moldova?
Make the answer very short. -0.02. In the year 2008, what is the difference between the General Parity Index (GPI) in Cyprus and General Parity Index (GPI) in Syrian Arab Republic?
Make the answer very short. 0.01. In the year 2008, what is the difference between the General Parity Index (GPI) of Iceland and General Parity Index (GPI) of Moldova?
Make the answer very short. 0.01. In the year 2008, what is the difference between the General Parity Index (GPI) of Iceland and General Parity Index (GPI) of Syrian Arab Republic?
Your answer should be very brief. 0.03. In the year 2008, what is the difference between the General Parity Index (GPI) in Moldova and General Parity Index (GPI) in Syrian Arab Republic?
Your response must be concise. 0.03. What is the ratio of the General Parity Index (GPI) in Cyprus in 2001 to that in 2002?
Offer a terse response. 0.99. What is the ratio of the General Parity Index (GPI) in Iceland in 2001 to that in 2002?
Provide a short and direct response. 1. What is the ratio of the General Parity Index (GPI) in Moldova in 2001 to that in 2002?
Make the answer very short. 0.99. What is the ratio of the General Parity Index (GPI) of Iceland in 2001 to that in 2003?
Offer a very short reply. 0.99. What is the ratio of the General Parity Index (GPI) in Syrian Arab Republic in 2001 to that in 2003?
Provide a succinct answer. 0.96. What is the ratio of the General Parity Index (GPI) of Cyprus in 2001 to that in 2004?
Ensure brevity in your answer.  0.98. What is the ratio of the General Parity Index (GPI) in Iceland in 2001 to that in 2004?
Offer a terse response. 1.03. What is the ratio of the General Parity Index (GPI) in Moldova in 2001 to that in 2004?
Provide a succinct answer. 0.98. What is the ratio of the General Parity Index (GPI) of Syrian Arab Republic in 2001 to that in 2004?
Your answer should be very brief. 0.95. What is the ratio of the General Parity Index (GPI) of Iceland in 2001 to that in 2005?
Offer a very short reply. 1.03. What is the ratio of the General Parity Index (GPI) of Syrian Arab Republic in 2001 to that in 2005?
Your response must be concise. 0.95. What is the ratio of the General Parity Index (GPI) of Iceland in 2001 to that in 2006?
Provide a succinct answer. 1.03. What is the ratio of the General Parity Index (GPI) of Moldova in 2001 to that in 2006?
Offer a very short reply. 0.98. What is the ratio of the General Parity Index (GPI) of Syrian Arab Republic in 2001 to that in 2006?
Give a very brief answer. 0.93. What is the ratio of the General Parity Index (GPI) in Cyprus in 2001 to that in 2007?
Offer a terse response. 0.99. What is the ratio of the General Parity Index (GPI) in Iceland in 2001 to that in 2007?
Ensure brevity in your answer.  1. What is the ratio of the General Parity Index (GPI) of Moldova in 2001 to that in 2007?
Offer a terse response. 0.99. What is the ratio of the General Parity Index (GPI) of Syrian Arab Republic in 2001 to that in 2007?
Offer a very short reply. 0.91. What is the ratio of the General Parity Index (GPI) of Cyprus in 2001 to that in 2008?
Keep it short and to the point. 1. What is the ratio of the General Parity Index (GPI) of Iceland in 2001 to that in 2008?
Give a very brief answer. 1.02. What is the ratio of the General Parity Index (GPI) of Syrian Arab Republic in 2001 to that in 2008?
Your answer should be very brief. 0.9. What is the ratio of the General Parity Index (GPI) of Cyprus in 2002 to that in 2003?
Provide a succinct answer. 1. What is the ratio of the General Parity Index (GPI) of Iceland in 2002 to that in 2003?
Ensure brevity in your answer.  0.99. What is the ratio of the General Parity Index (GPI) of Moldova in 2002 to that in 2003?
Ensure brevity in your answer.  0.99. What is the ratio of the General Parity Index (GPI) of Syrian Arab Republic in 2002 to that in 2003?
Offer a very short reply. 0.97. What is the ratio of the General Parity Index (GPI) in Iceland in 2002 to that in 2004?
Your answer should be compact. 1.02. What is the ratio of the General Parity Index (GPI) in Moldova in 2002 to that in 2004?
Your answer should be compact. 0.98. What is the ratio of the General Parity Index (GPI) in Syrian Arab Republic in 2002 to that in 2004?
Ensure brevity in your answer.  0.96. What is the ratio of the General Parity Index (GPI) in Iceland in 2002 to that in 2005?
Offer a very short reply. 1.03. What is the ratio of the General Parity Index (GPI) in Moldova in 2002 to that in 2005?
Provide a short and direct response. 0.99. What is the ratio of the General Parity Index (GPI) of Syrian Arab Republic in 2002 to that in 2005?
Offer a very short reply. 0.95. What is the ratio of the General Parity Index (GPI) in Cyprus in 2002 to that in 2006?
Your answer should be very brief. 1. What is the ratio of the General Parity Index (GPI) of Iceland in 2002 to that in 2006?
Provide a short and direct response. 1.03. What is the ratio of the General Parity Index (GPI) in Moldova in 2002 to that in 2006?
Keep it short and to the point. 0.99. What is the ratio of the General Parity Index (GPI) of Syrian Arab Republic in 2002 to that in 2006?
Ensure brevity in your answer.  0.94. What is the ratio of the General Parity Index (GPI) of Cyprus in 2002 to that in 2007?
Make the answer very short. 1. What is the ratio of the General Parity Index (GPI) in Moldova in 2002 to that in 2007?
Ensure brevity in your answer.  1. What is the ratio of the General Parity Index (GPI) in Syrian Arab Republic in 2002 to that in 2007?
Keep it short and to the point. 0.92. What is the ratio of the General Parity Index (GPI) of Cyprus in 2002 to that in 2008?
Your answer should be compact. 1.01. What is the ratio of the General Parity Index (GPI) in Iceland in 2002 to that in 2008?
Provide a short and direct response. 1.02. What is the ratio of the General Parity Index (GPI) in Moldova in 2002 to that in 2008?
Offer a terse response. 1. What is the ratio of the General Parity Index (GPI) of Syrian Arab Republic in 2002 to that in 2008?
Your response must be concise. 0.91. What is the ratio of the General Parity Index (GPI) of Cyprus in 2003 to that in 2004?
Keep it short and to the point. 0.99. What is the ratio of the General Parity Index (GPI) in Iceland in 2003 to that in 2004?
Offer a terse response. 1.03. What is the ratio of the General Parity Index (GPI) in Moldova in 2003 to that in 2004?
Offer a terse response. 0.99. What is the ratio of the General Parity Index (GPI) in Iceland in 2003 to that in 2005?
Offer a very short reply. 1.04. What is the ratio of the General Parity Index (GPI) in Moldova in 2003 to that in 2005?
Give a very brief answer. 0.99. What is the ratio of the General Parity Index (GPI) of Syrian Arab Republic in 2003 to that in 2005?
Ensure brevity in your answer.  0.98. What is the ratio of the General Parity Index (GPI) in Cyprus in 2003 to that in 2006?
Your response must be concise. 1. What is the ratio of the General Parity Index (GPI) of Iceland in 2003 to that in 2006?
Your answer should be compact. 1.04. What is the ratio of the General Parity Index (GPI) of Moldova in 2003 to that in 2006?
Your response must be concise. 0.99. What is the ratio of the General Parity Index (GPI) of Syrian Arab Republic in 2003 to that in 2006?
Provide a short and direct response. 0.97. What is the ratio of the General Parity Index (GPI) in Cyprus in 2003 to that in 2007?
Your answer should be compact. 1. What is the ratio of the General Parity Index (GPI) in Iceland in 2003 to that in 2007?
Provide a short and direct response. 1.01. What is the ratio of the General Parity Index (GPI) in Syrian Arab Republic in 2003 to that in 2007?
Offer a terse response. 0.94. What is the ratio of the General Parity Index (GPI) of Iceland in 2003 to that in 2008?
Offer a terse response. 1.03. What is the ratio of the General Parity Index (GPI) of Syrian Arab Republic in 2003 to that in 2008?
Provide a succinct answer. 0.93. What is the ratio of the General Parity Index (GPI) in Cyprus in 2004 to that in 2005?
Your response must be concise. 1.01. What is the ratio of the General Parity Index (GPI) of Iceland in 2004 to that in 2005?
Your answer should be very brief. 1.01. What is the ratio of the General Parity Index (GPI) in Syrian Arab Republic in 2004 to that in 2005?
Offer a terse response. 0.99. What is the ratio of the General Parity Index (GPI) of Cyprus in 2004 to that in 2006?
Make the answer very short. 1.01. What is the ratio of the General Parity Index (GPI) of Iceland in 2004 to that in 2006?
Offer a terse response. 1. What is the ratio of the General Parity Index (GPI) in Syrian Arab Republic in 2004 to that in 2006?
Your answer should be very brief. 0.98. What is the ratio of the General Parity Index (GPI) of Cyprus in 2004 to that in 2007?
Keep it short and to the point. 1.01. What is the ratio of the General Parity Index (GPI) in Iceland in 2004 to that in 2007?
Offer a very short reply. 0.97. What is the ratio of the General Parity Index (GPI) of Moldova in 2004 to that in 2007?
Give a very brief answer. 1.02. What is the ratio of the General Parity Index (GPI) in Syrian Arab Republic in 2004 to that in 2007?
Keep it short and to the point. 0.95. What is the ratio of the General Parity Index (GPI) in Cyprus in 2004 to that in 2008?
Your answer should be compact. 1.02. What is the ratio of the General Parity Index (GPI) of Moldova in 2004 to that in 2008?
Ensure brevity in your answer.  1.02. What is the ratio of the General Parity Index (GPI) in Syrian Arab Republic in 2004 to that in 2008?
Keep it short and to the point. 0.94. What is the ratio of the General Parity Index (GPI) of Moldova in 2005 to that in 2006?
Your answer should be compact. 1. What is the ratio of the General Parity Index (GPI) of Syrian Arab Republic in 2005 to that in 2006?
Provide a short and direct response. 0.98. What is the ratio of the General Parity Index (GPI) in Iceland in 2005 to that in 2007?
Offer a very short reply. 0.97. What is the ratio of the General Parity Index (GPI) in Syrian Arab Republic in 2005 to that in 2007?
Provide a succinct answer. 0.96. What is the ratio of the General Parity Index (GPI) of Cyprus in 2005 to that in 2008?
Your answer should be very brief. 1.01. What is the ratio of the General Parity Index (GPI) of Iceland in 2005 to that in 2008?
Offer a terse response. 0.99. What is the ratio of the General Parity Index (GPI) of Moldova in 2005 to that in 2008?
Offer a very short reply. 1.01. What is the ratio of the General Parity Index (GPI) in Syrian Arab Republic in 2005 to that in 2008?
Your response must be concise. 0.95. What is the ratio of the General Parity Index (GPI) of Iceland in 2006 to that in 2007?
Provide a succinct answer. 0.97. What is the ratio of the General Parity Index (GPI) in Moldova in 2006 to that in 2007?
Offer a very short reply. 1.01. What is the ratio of the General Parity Index (GPI) of Syrian Arab Republic in 2006 to that in 2007?
Your answer should be compact. 0.98. What is the ratio of the General Parity Index (GPI) in Cyprus in 2006 to that in 2008?
Make the answer very short. 1.01. What is the ratio of the General Parity Index (GPI) in Moldova in 2006 to that in 2008?
Your answer should be very brief. 1.01. What is the ratio of the General Parity Index (GPI) of Syrian Arab Republic in 2006 to that in 2008?
Your response must be concise. 0.97. What is the ratio of the General Parity Index (GPI) in Iceland in 2007 to that in 2008?
Make the answer very short. 1.02. What is the ratio of the General Parity Index (GPI) of Moldova in 2007 to that in 2008?
Offer a very short reply. 1. What is the ratio of the General Parity Index (GPI) in Syrian Arab Republic in 2007 to that in 2008?
Your answer should be compact. 0.99. What is the difference between the highest and the second highest General Parity Index (GPI) in Cyprus?
Your answer should be compact. 0.01. What is the difference between the highest and the second highest General Parity Index (GPI) in Iceland?
Offer a terse response. 0.01. What is the difference between the highest and the second highest General Parity Index (GPI) of Moldova?
Keep it short and to the point. 0. What is the difference between the highest and the second highest General Parity Index (GPI) of Syrian Arab Republic?
Your answer should be compact. 0.01. What is the difference between the highest and the lowest General Parity Index (GPI) of Cyprus?
Give a very brief answer. 0.02. What is the difference between the highest and the lowest General Parity Index (GPI) of Iceland?
Provide a succinct answer. 0.04. What is the difference between the highest and the lowest General Parity Index (GPI) of Moldova?
Offer a very short reply. 0.02. What is the difference between the highest and the lowest General Parity Index (GPI) of Syrian Arab Republic?
Your answer should be very brief. 0.1. 